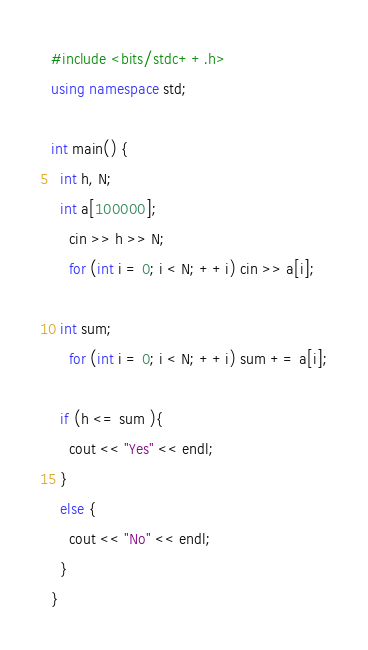Convert code to text. <code><loc_0><loc_0><loc_500><loc_500><_C++_>#include <bits/stdc++.h>
using namespace std;

int main() {
  int h, N;
  int a[100000];
    cin >> h >> N;
    for (int i = 0; i < N; ++i) cin >> a[i];
   
  int sum;
    for (int i = 0; i < N; ++i) sum += a[i];
   
  if (h <= sum ){
    cout << "Yes" << endl;
  }
  else {
    cout << "No" << endl;
  }
}
</code> 